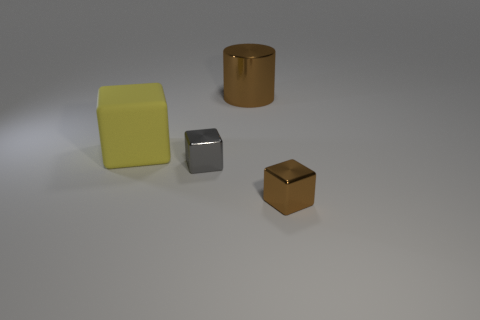Add 3 brown cubes. How many objects exist? 7 Subtract all cubes. How many objects are left? 1 Subtract all cylinders. Subtract all big matte objects. How many objects are left? 2 Add 3 yellow blocks. How many yellow blocks are left? 4 Add 1 tiny gray things. How many tiny gray things exist? 2 Subtract 0 red balls. How many objects are left? 4 